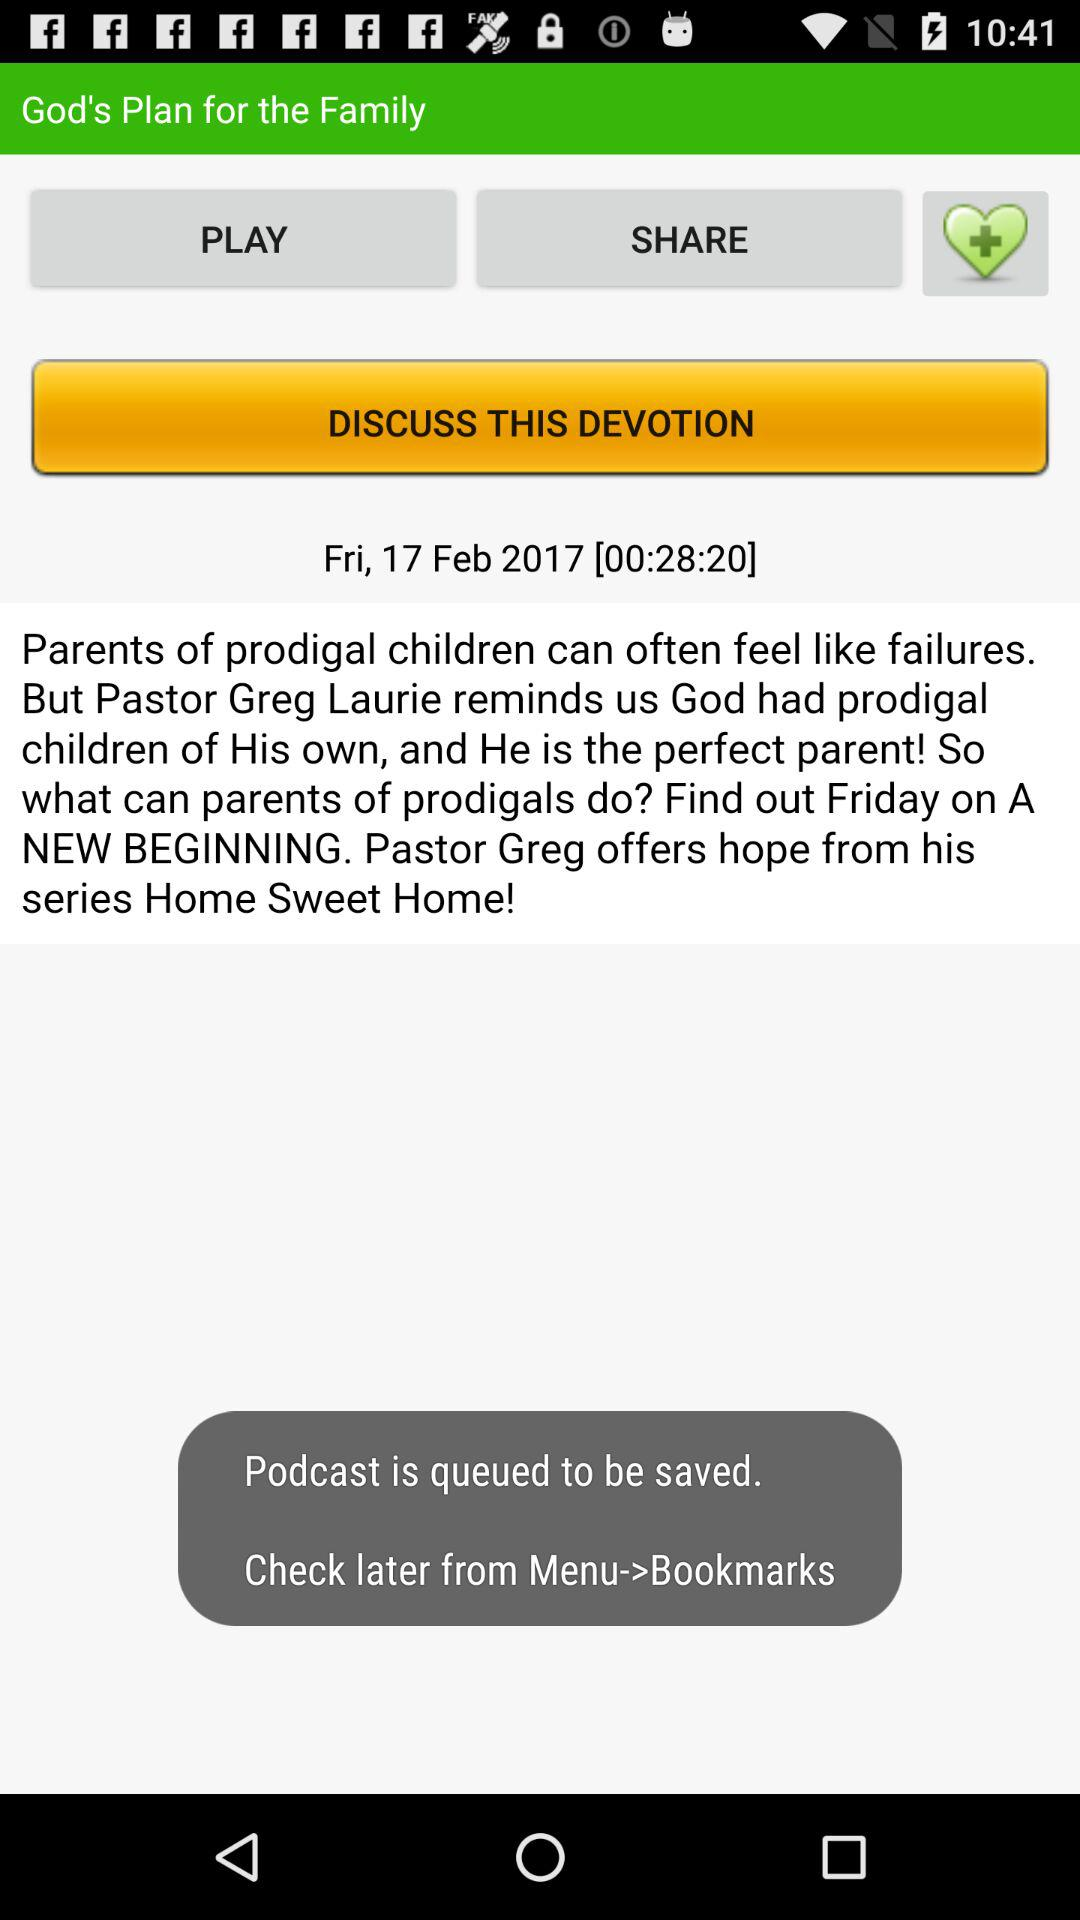What is the duration of the devotion? The duration of the devotion is 28 minutes and 20 seconds. 